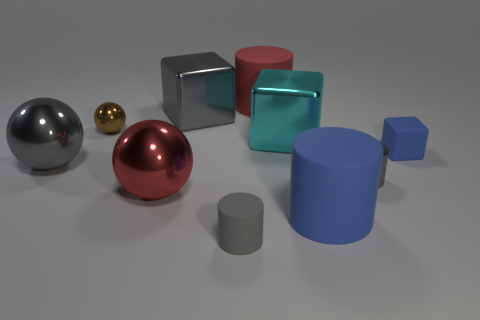How many other objects are there of the same color as the small matte cube?
Provide a succinct answer. 1. Do the matte block and the big matte cylinder that is in front of the tiny blue cube have the same color?
Your answer should be very brief. Yes. There is a matte cylinder that is the same color as the small metal cylinder; what is its size?
Provide a short and direct response. Small. There is a gray cylinder that is on the left side of the large cylinder behind the red ball; what is it made of?
Give a very brief answer. Rubber. Are there fewer spheres that are behind the big cyan block than tiny objects that are on the left side of the blue cylinder?
Your answer should be compact. Yes. What number of red things are metal spheres or small shiny cylinders?
Offer a very short reply. 1. Are there the same number of balls that are on the right side of the red matte object and tiny gray rubber cubes?
Provide a succinct answer. Yes. How many things are either big gray spheres or big gray metal objects in front of the small brown shiny thing?
Keep it short and to the point. 1. Do the metal cylinder and the small rubber cylinder have the same color?
Provide a succinct answer. Yes. Are there any gray objects made of the same material as the blue cube?
Provide a succinct answer. Yes. 